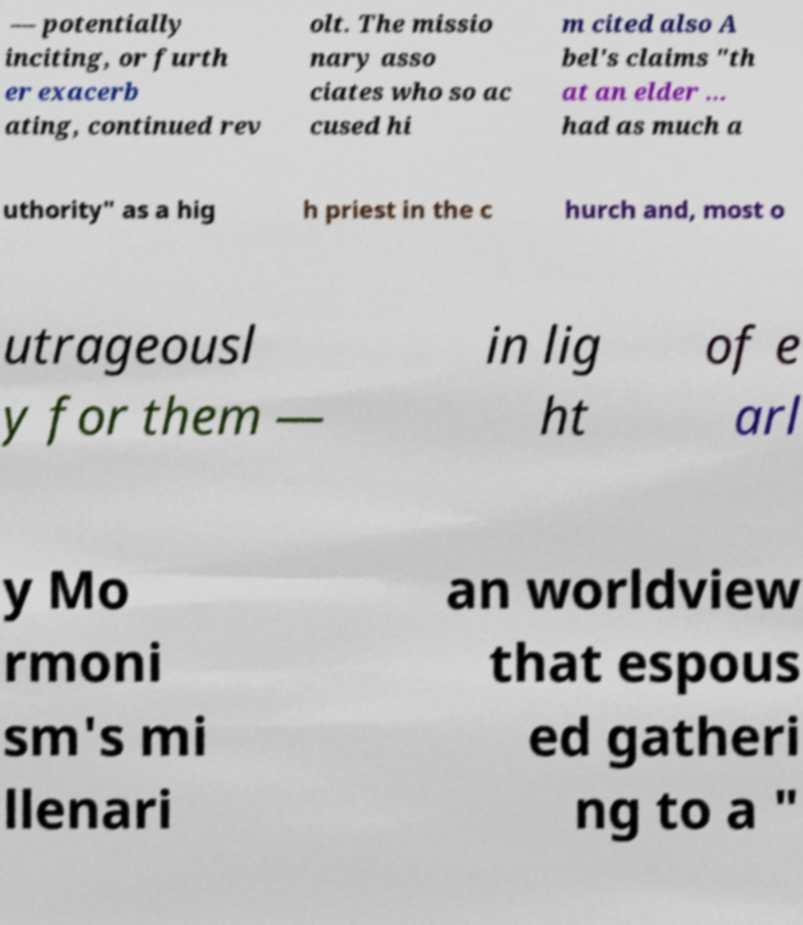Please read and relay the text visible in this image. What does it say? — potentially inciting, or furth er exacerb ating, continued rev olt. The missio nary asso ciates who so ac cused hi m cited also A bel's claims "th at an elder ... had as much a uthority" as a hig h priest in the c hurch and, most o utrageousl y for them — in lig ht of e arl y Mo rmoni sm's mi llenari an worldview that espous ed gatheri ng to a " 